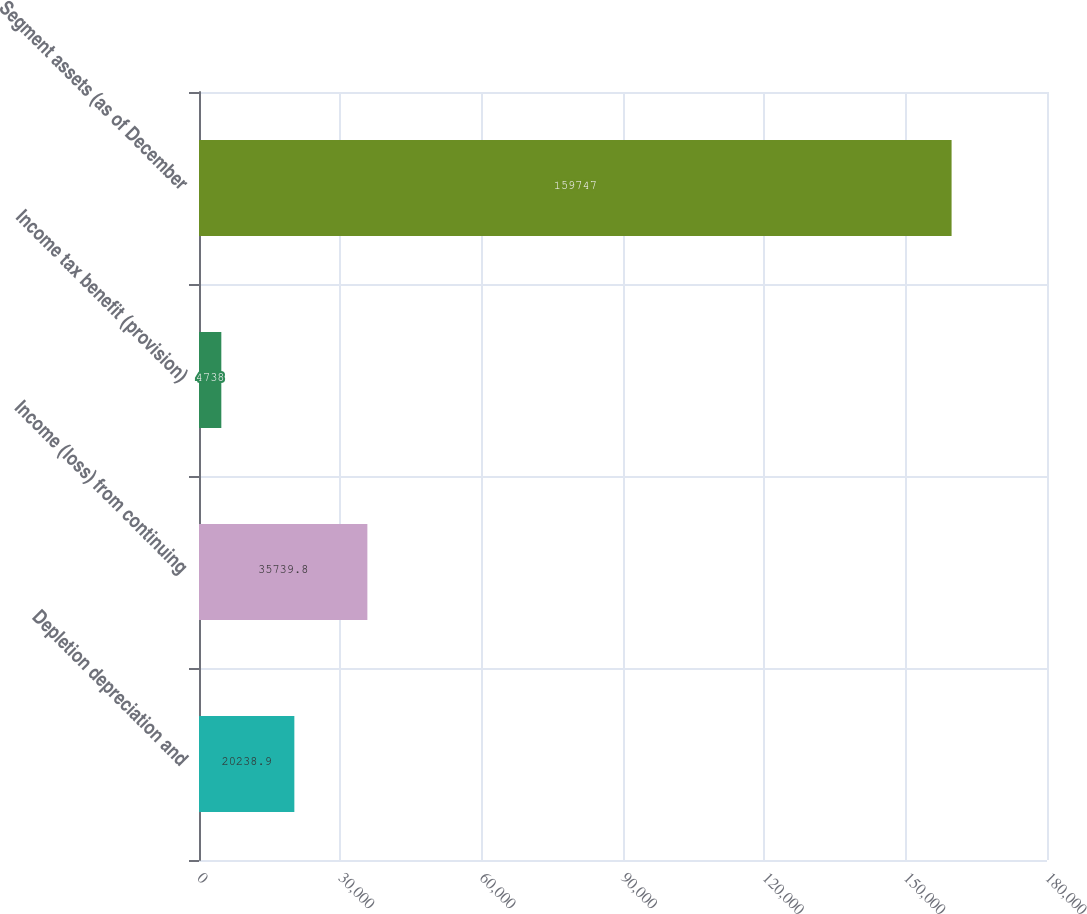Convert chart to OTSL. <chart><loc_0><loc_0><loc_500><loc_500><bar_chart><fcel>Depletion depreciation and<fcel>Income (loss) from continuing<fcel>Income tax benefit (provision)<fcel>Segment assets (as of December<nl><fcel>20238.9<fcel>35739.8<fcel>4738<fcel>159747<nl></chart> 